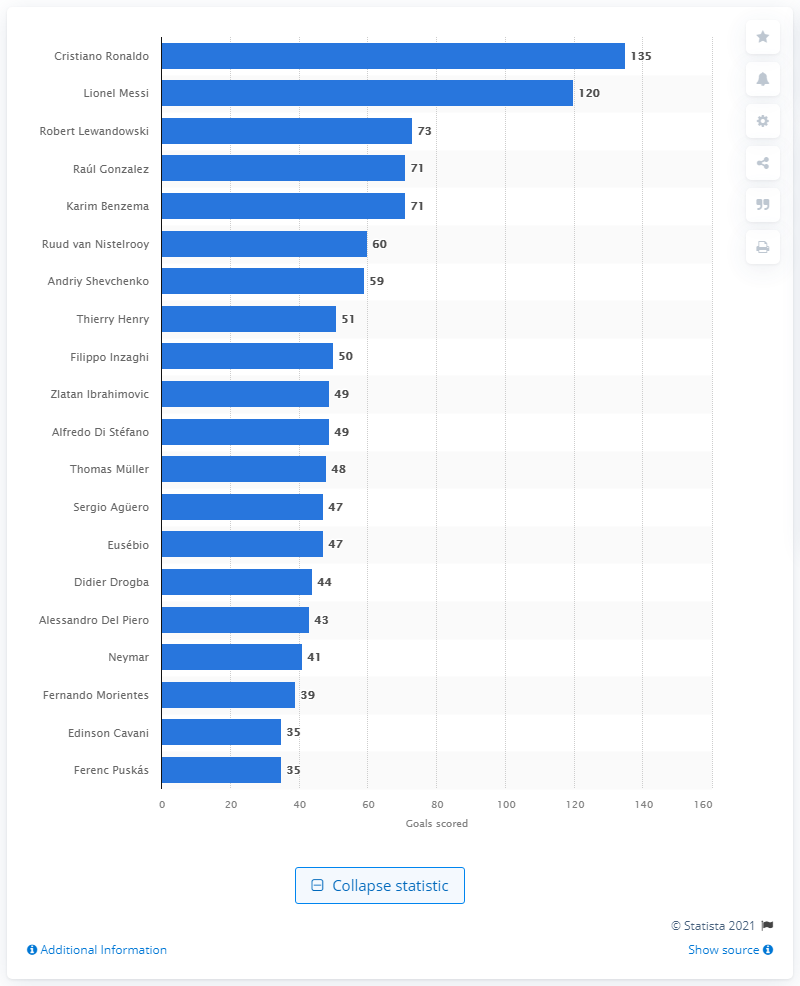Indicate a few pertinent items in this graphic. Cristiano Ronaldo has scored a total of 135 goals in the UEFA Champions League throughout his career, making him one of the all-time leading scorers in the competition. Lionel Messi, who sits in second place with 120 goals, is the person who is mentioned. Robert Lewandowski is the third-highest scorer in the UEFA Champions League. 